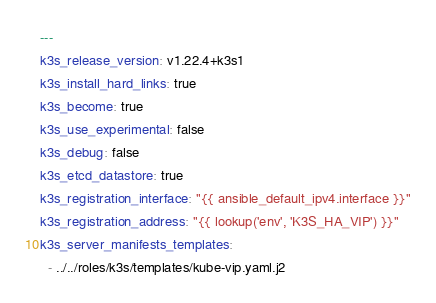Convert code to text. <code><loc_0><loc_0><loc_500><loc_500><_YAML_>---
k3s_release_version: v1.22.4+k3s1
k3s_install_hard_links: true
k3s_become: true
k3s_use_experimental: false
k3s_debug: false
k3s_etcd_datastore: true
k3s_registration_interface: "{{ ansible_default_ipv4.interface }}"
k3s_registration_address: "{{ lookup('env', 'K3S_HA_VIP') }}"
k3s_server_manifests_templates:
  - ../../roles/k3s/templates/kube-vip.yaml.j2
</code> 